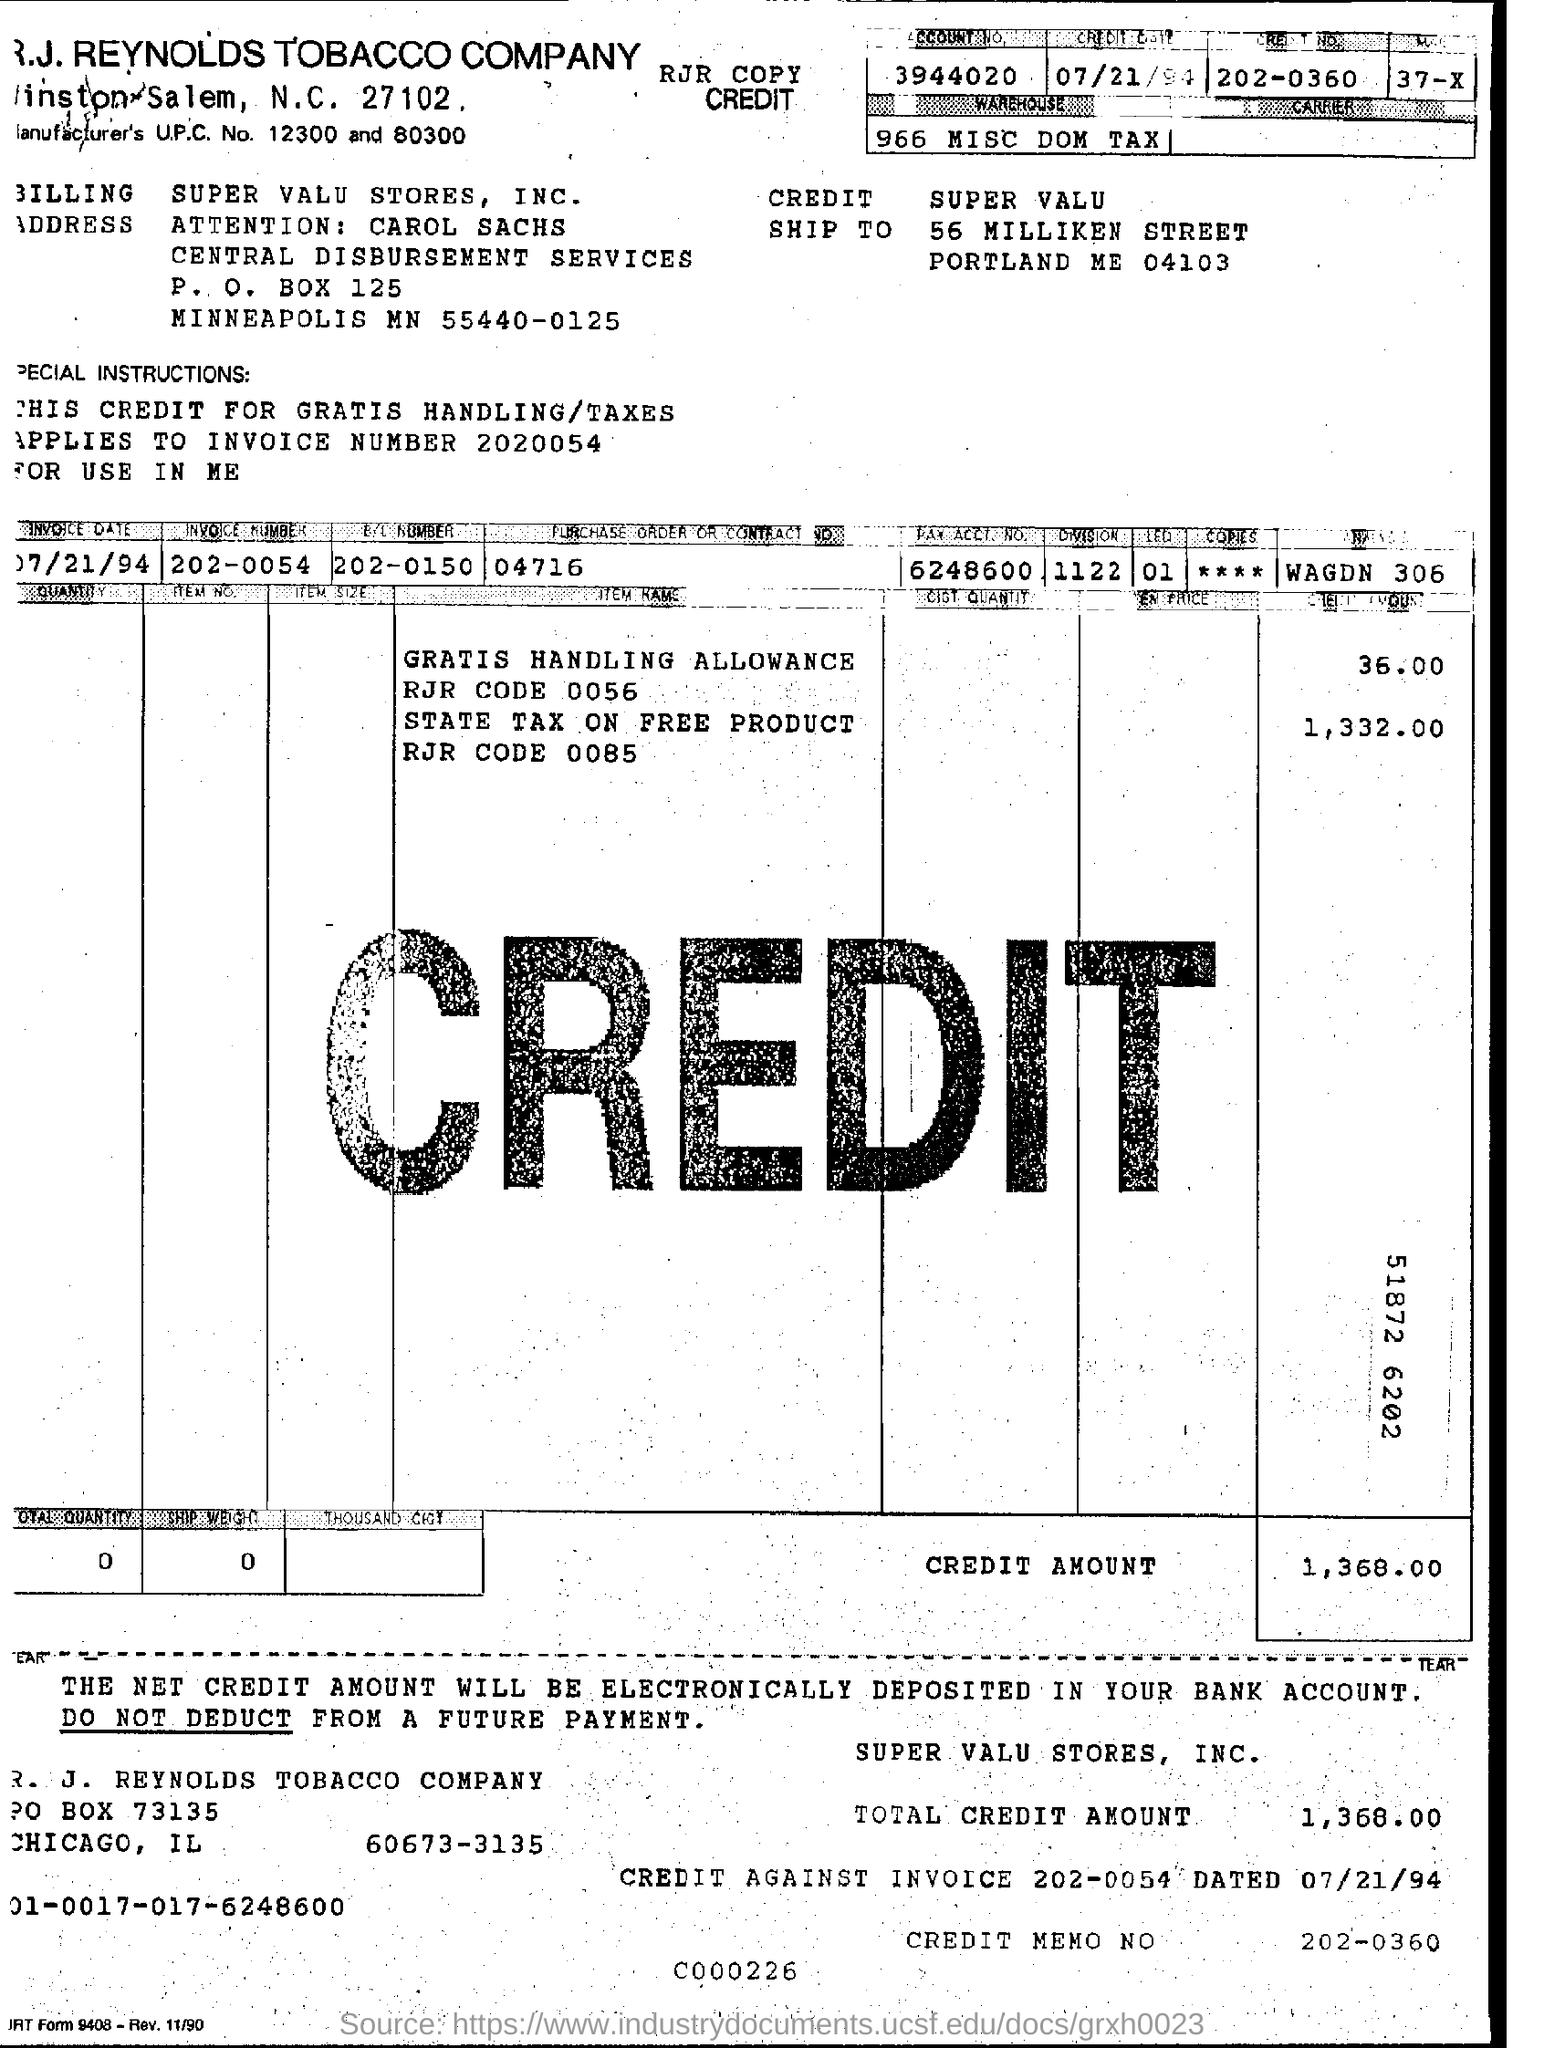Point out several critical features in this image. R.J. Reynolds Tobacco Company is a company name. The credit memo number is 202-0360. The P.O Box Number of the document is 125. The total credit amount is 1,368.00. 